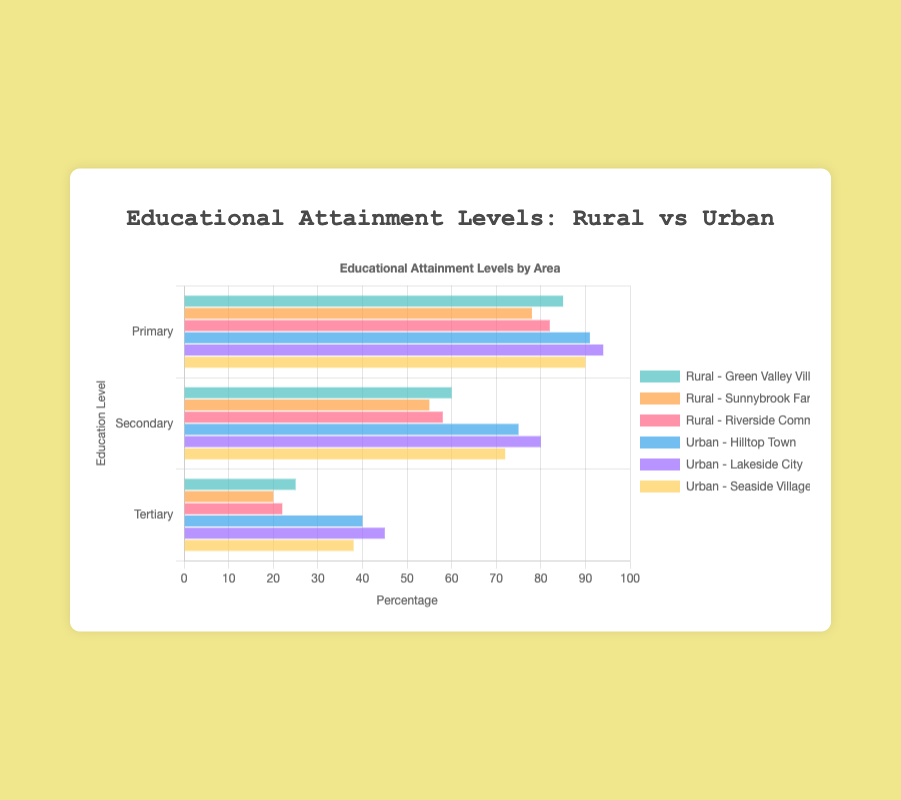Which area has the highest percentage of children achieving primary education? Look at the bars representing primary education levels. The tallest bars for primary education are seen in urban areas. Hilltop Town has 91%, Lakeside City has 94%, and Seaside Village has 90%. The highest is in Lakeside City with 94%.
Answer: Lakeside City Compare the difference in secondary education attainment between Green Valley Village and Lakeside City. Identify the secondary education bars for Green Valley Village (Rural) and Lakeside City (Urban). Green Valley Village has 60% and Lakeside City has 80%. Subtract the smaller percentage from the larger one: 80% - 60% = 20%.
Answer: 20% What is the average tertiary education attainment in urban areas? Gather the tertiary education percentages for urban areas: Hilltop Town (40%), Lakeside City (45%), and Seaside Village (38%). Calculate the average: (40% + 45% + 38%) / 3 = 41%.
Answer: 41% Which rural area has the lowest attainment for tertiary education? Look at all the bars representing tertiary education levels for rural areas. The bars you need to compare are for Green Valley Village (25%), Sunnybrook Farm (20%), and Riverside Commune (22%). The lowest percentage is at Sunnybrook Farm with 20%.
Answer: Sunnybrook Farm Is secondary education attainment generally higher in urban or rural areas? Compare the overall pattern of secondary education percentages between rural and urban areas. Urban percentages are Hilltop Town (75%), Lakeside City (80%), and Seaside Village (72%). Rural percentages are Green Valley Village (60%), Sunnybrook Farm (55%), and Riverside Commune (58%). Urban areas consistently have higher percentages in secondary education.
Answer: Urban What is the combined percentage of children in Green Valley Village achieving primary or secondary education? Locate the percentages for primary and secondary education in Green Valley Village: Primary (85%) and Secondary (60%). Combine these percentages: 85% + 60% = 145%.
Answer: 145% By how much does primary education attainment in Sunnybrook Farm differ from Seaside Village? Compare the primary education percentages for Sunnybrook Farm (78%) and Seaside Village (90%). Calculate the difference: 90% - 78% = 12%.
Answer: 12% Do urban or rural areas have more consistent tertiary education attainment levels? Review the spread of tertiary education attainment levels. For rural areas: Green Valley Village (25%), Sunnybrook Farm (20%), and Riverside Commune (22%). For urban areas: Hilltop Town (40%), Lakeside City (45%), and Seaside Village (38%). Rural areas show less variation (25% to 20% = 5% range) compared to urban areas (45% to 38% = 7% range). Rural areas are more consistent.
Answer: Rural 